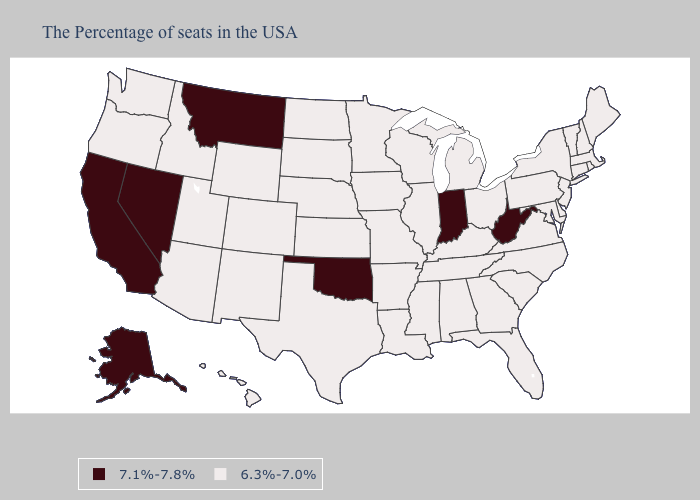Which states have the lowest value in the West?
Answer briefly. Wyoming, Colorado, New Mexico, Utah, Arizona, Idaho, Washington, Oregon, Hawaii. Name the states that have a value in the range 6.3%-7.0%?
Answer briefly. Maine, Massachusetts, Rhode Island, New Hampshire, Vermont, Connecticut, New York, New Jersey, Delaware, Maryland, Pennsylvania, Virginia, North Carolina, South Carolina, Ohio, Florida, Georgia, Michigan, Kentucky, Alabama, Tennessee, Wisconsin, Illinois, Mississippi, Louisiana, Missouri, Arkansas, Minnesota, Iowa, Kansas, Nebraska, Texas, South Dakota, North Dakota, Wyoming, Colorado, New Mexico, Utah, Arizona, Idaho, Washington, Oregon, Hawaii. Name the states that have a value in the range 7.1%-7.8%?
Be succinct. West Virginia, Indiana, Oklahoma, Montana, Nevada, California, Alaska. Name the states that have a value in the range 6.3%-7.0%?
Give a very brief answer. Maine, Massachusetts, Rhode Island, New Hampshire, Vermont, Connecticut, New York, New Jersey, Delaware, Maryland, Pennsylvania, Virginia, North Carolina, South Carolina, Ohio, Florida, Georgia, Michigan, Kentucky, Alabama, Tennessee, Wisconsin, Illinois, Mississippi, Louisiana, Missouri, Arkansas, Minnesota, Iowa, Kansas, Nebraska, Texas, South Dakota, North Dakota, Wyoming, Colorado, New Mexico, Utah, Arizona, Idaho, Washington, Oregon, Hawaii. Name the states that have a value in the range 6.3%-7.0%?
Concise answer only. Maine, Massachusetts, Rhode Island, New Hampshire, Vermont, Connecticut, New York, New Jersey, Delaware, Maryland, Pennsylvania, Virginia, North Carolina, South Carolina, Ohio, Florida, Georgia, Michigan, Kentucky, Alabama, Tennessee, Wisconsin, Illinois, Mississippi, Louisiana, Missouri, Arkansas, Minnesota, Iowa, Kansas, Nebraska, Texas, South Dakota, North Dakota, Wyoming, Colorado, New Mexico, Utah, Arizona, Idaho, Washington, Oregon, Hawaii. Name the states that have a value in the range 6.3%-7.0%?
Write a very short answer. Maine, Massachusetts, Rhode Island, New Hampshire, Vermont, Connecticut, New York, New Jersey, Delaware, Maryland, Pennsylvania, Virginia, North Carolina, South Carolina, Ohio, Florida, Georgia, Michigan, Kentucky, Alabama, Tennessee, Wisconsin, Illinois, Mississippi, Louisiana, Missouri, Arkansas, Minnesota, Iowa, Kansas, Nebraska, Texas, South Dakota, North Dakota, Wyoming, Colorado, New Mexico, Utah, Arizona, Idaho, Washington, Oregon, Hawaii. Which states have the highest value in the USA?
Answer briefly. West Virginia, Indiana, Oklahoma, Montana, Nevada, California, Alaska. What is the value of Colorado?
Keep it brief. 6.3%-7.0%. Name the states that have a value in the range 6.3%-7.0%?
Keep it brief. Maine, Massachusetts, Rhode Island, New Hampshire, Vermont, Connecticut, New York, New Jersey, Delaware, Maryland, Pennsylvania, Virginia, North Carolina, South Carolina, Ohio, Florida, Georgia, Michigan, Kentucky, Alabama, Tennessee, Wisconsin, Illinois, Mississippi, Louisiana, Missouri, Arkansas, Minnesota, Iowa, Kansas, Nebraska, Texas, South Dakota, North Dakota, Wyoming, Colorado, New Mexico, Utah, Arizona, Idaho, Washington, Oregon, Hawaii. What is the value of Delaware?
Write a very short answer. 6.3%-7.0%. Does Indiana have the highest value in the MidWest?
Answer briefly. Yes. How many symbols are there in the legend?
Give a very brief answer. 2. Name the states that have a value in the range 6.3%-7.0%?
Keep it brief. Maine, Massachusetts, Rhode Island, New Hampshire, Vermont, Connecticut, New York, New Jersey, Delaware, Maryland, Pennsylvania, Virginia, North Carolina, South Carolina, Ohio, Florida, Georgia, Michigan, Kentucky, Alabama, Tennessee, Wisconsin, Illinois, Mississippi, Louisiana, Missouri, Arkansas, Minnesota, Iowa, Kansas, Nebraska, Texas, South Dakota, North Dakota, Wyoming, Colorado, New Mexico, Utah, Arizona, Idaho, Washington, Oregon, Hawaii. What is the value of Utah?
Give a very brief answer. 6.3%-7.0%. 